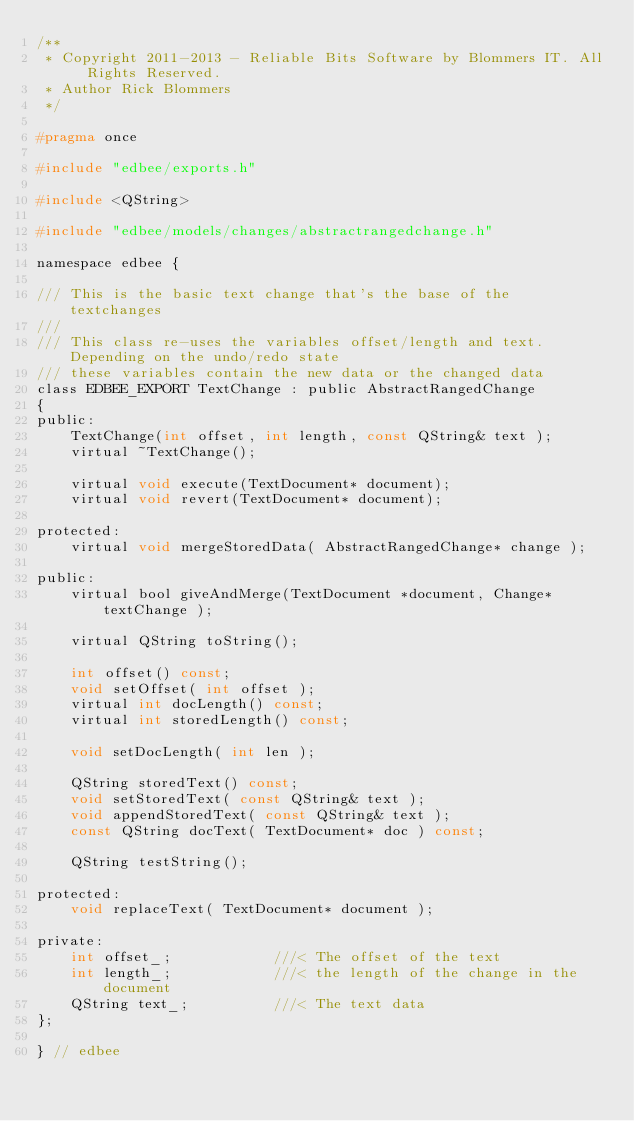Convert code to text. <code><loc_0><loc_0><loc_500><loc_500><_C_>/**
 * Copyright 2011-2013 - Reliable Bits Software by Blommers IT. All Rights Reserved.
 * Author Rick Blommers
 */

#pragma once

#include "edbee/exports.h"

#include <QString>

#include "edbee/models/changes/abstractrangedchange.h"

namespace edbee {

/// This is the basic text change that's the base of the textchanges
///
/// This class re-uses the variables offset/length and text. Depending on the undo/redo state
/// these variables contain the new data or the changed data
class EDBEE_EXPORT TextChange : public AbstractRangedChange
{
public:
    TextChange(int offset, int length, const QString& text );
    virtual ~TextChange();

    virtual void execute(TextDocument* document);
    virtual void revert(TextDocument* document);

protected:
    virtual void mergeStoredData( AbstractRangedChange* change );

public:
    virtual bool giveAndMerge(TextDocument *document, Change* textChange );

    virtual QString toString();

    int offset() const;
    void setOffset( int offset );
    virtual int docLength() const;
    virtual int storedLength() const;

    void setDocLength( int len );

    QString storedText() const;
    void setStoredText( const QString& text );
    void appendStoredText( const QString& text );
    const QString docText( TextDocument* doc ) const;

    QString testString();

protected:
    void replaceText( TextDocument* document );

private:
    int offset_;            ///< The offset of the text
    int length_;            ///< the length of the change in the document
    QString text_;          ///< The text data
};

} // edbee
</code> 